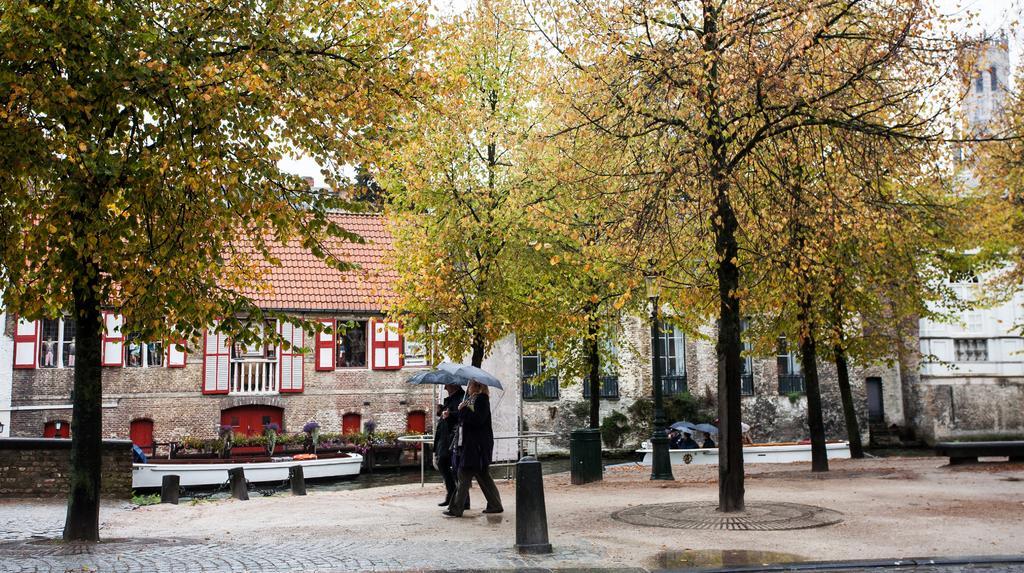In one or two sentences, can you explain what this image depicts? In the image we can see two people walking, wearing clothes and holding umbrellas, and we can see there are even people sitting. Here we can see footpath, plants and trees. Here we can see the building and the windows of the building and the sky. 